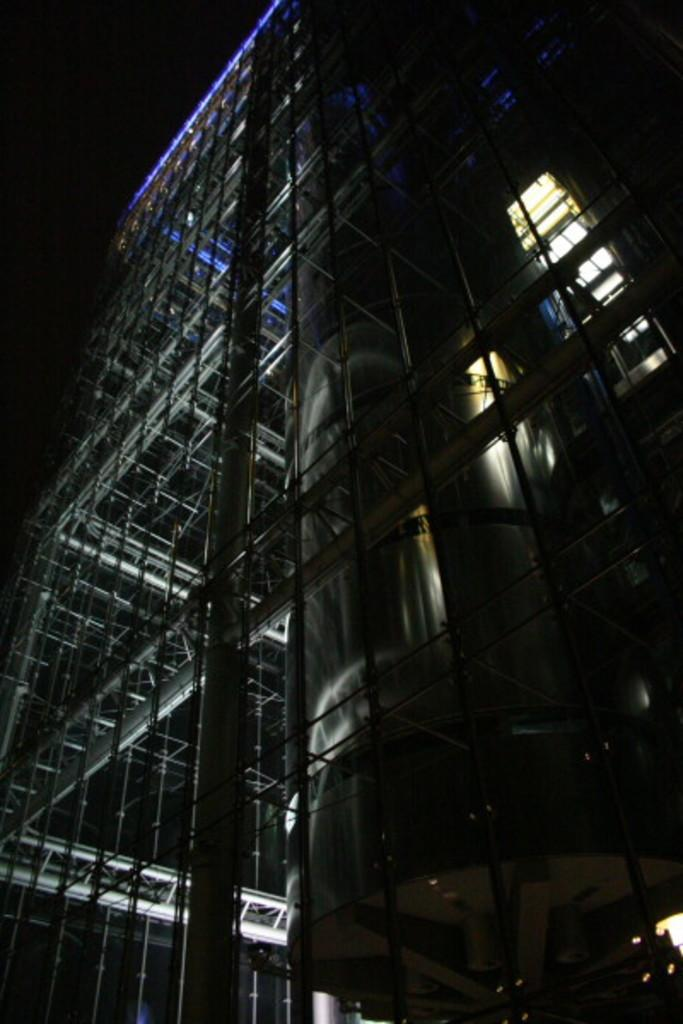What is the main structure in the image? There is a building in the image. How would you describe the lighting conditions at the top of the image? The top part of the image is dark. What can be seen inside the building? There are lights visible in the building. How many friends are sitting on the mountain in the image? There is no mountain or friends present in the image. 